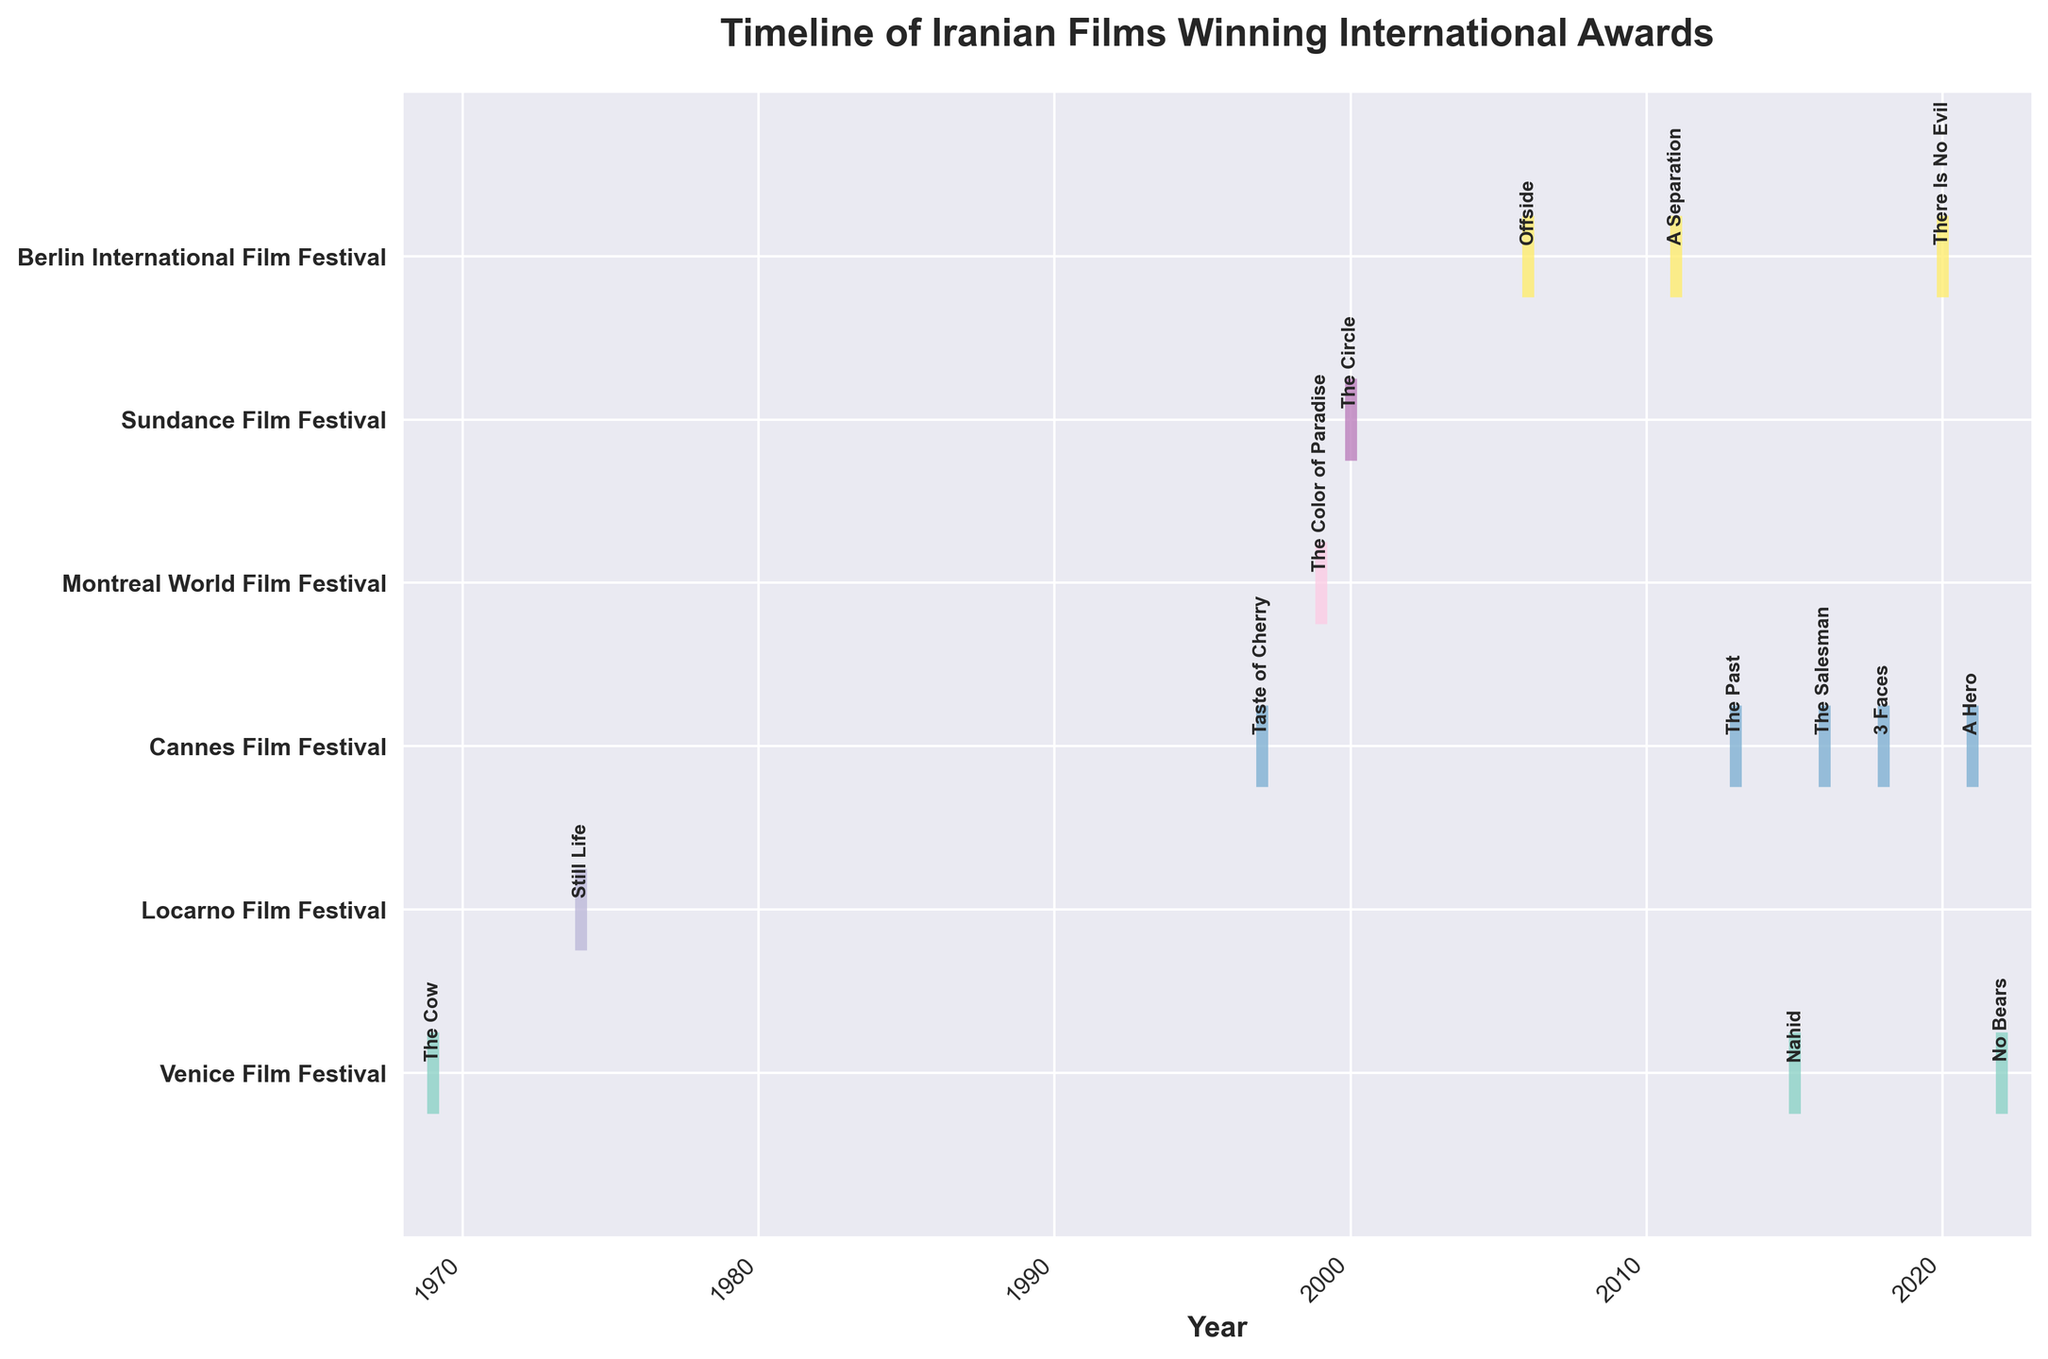What is the title of the plot? The title is displayed prominently at the top of the plot. It reads "Timeline of Iranian Films Winning International Awards".
Answer: Timeline of Iranian Films Winning International Awards Which festival appears most frequently in the figure? Count the occurrences of each festival in the y-axis labels. The Berlin International Film Festival appears three times.
Answer: Berlin International Film Festival In which years did Iranian films win awards at the Cannes Film Festival? Look for the location and label associated with Cannes Film Festival and note the x-axis values corresponding to this label. The years are 1997, 2013, 2016, 2018, and 2021.
Answer: 1997, 2013, 2016, 2018, 2021 Which film won an award at the Sundance Film Festival, and in which year? Identify the event plot line corresponding to the Sundance Film Festival and read the annotation for the film title and the associated year. The film "The Circle" won in 2000.
Answer: The Circle, 2000 How many unique festivals are represented in the plot? Count the number of unique festival labels on the y-axis. There are seven unique festivals.
Answer: 7 What is the most recent year in which an Iranian film won an award, and at which festival? Look for the highest value on the x-axis and read the corresponding y-axis label and annotation. The most recent year is 2022, at the Venice Film Festival with the film "No Bears".
Answer: 2022, Venice Film Festival How many years are there between the first and last award-winning films, and what are their titles? Subtract the year of the first award-winning film (1969) from the year of the last award-winning film (2022). The title of the first film is "The Cow" and the last is "No Bears".
Answer: 53 years, The Cow, No Bears Which festival has the longest gap between two consecutive awards for Iranian films, and what is the duration of this gap? Identify the two consecutive years for each festival and find the largest difference. The Venice Film Festival has a gap from 1969 to 2015, which is 46 years.
Answer: Venice Film Festival, 46 years Between the Berlin International Film Festival and Cannes Film Festival, which festival had a more recent award-winning film for Iran and in which year? Compare the most recent years for the Berlin International Film Festival (2020) and Cannes Film Festival (2021). The Cannes Film Festival had a more recent award in 2021.
Answer: Cannes Film Festival, 2021 